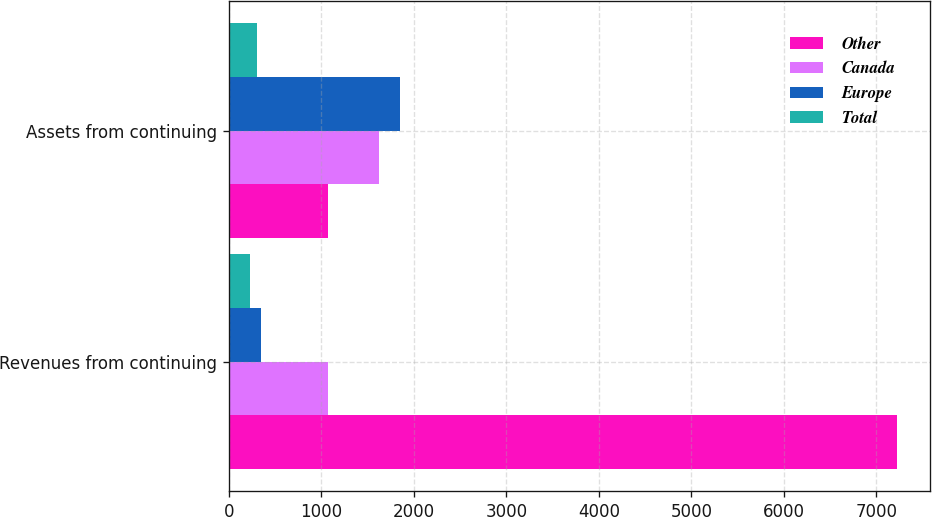<chart> <loc_0><loc_0><loc_500><loc_500><stacked_bar_chart><ecel><fcel>Revenues from continuing<fcel>Assets from continuing<nl><fcel>Other<fcel>7222.8<fcel>1076.5<nl><fcel>Canada<fcel>1076.5<fcel>1621.8<nl><fcel>Europe<fcel>343.4<fcel>1851.8<nl><fcel>Total<fcel>224.4<fcel>300.3<nl></chart> 